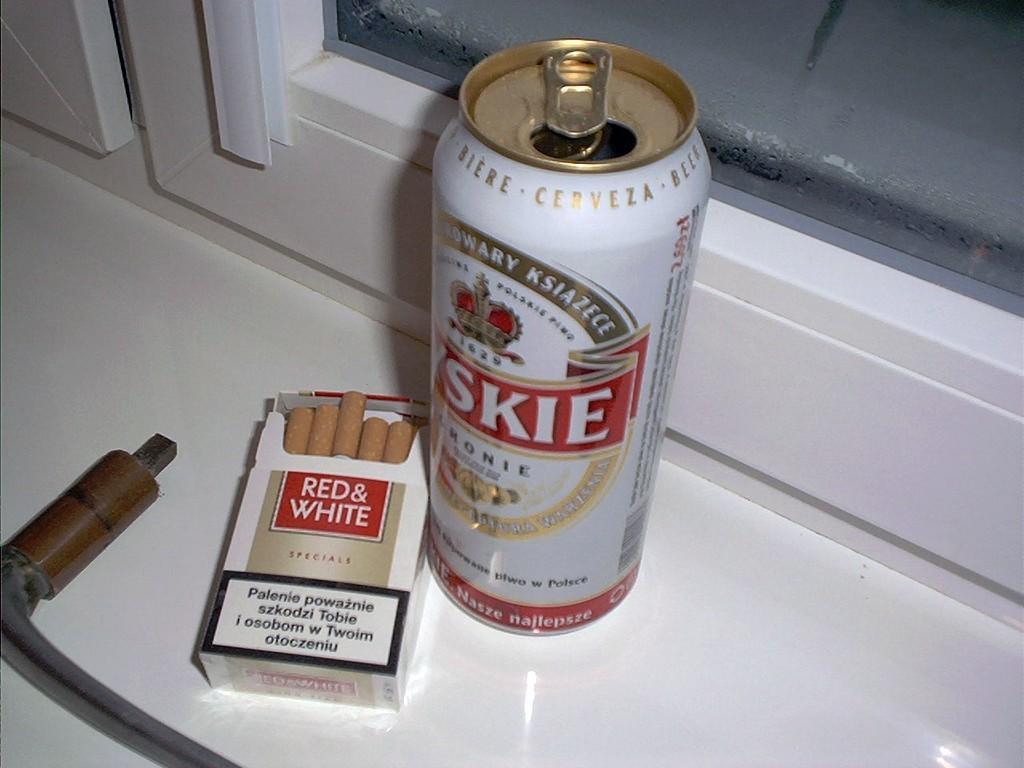Can you describe this image briefly? In the picture there is a cigarette pack with cigars in it, beside there is a tin, on the tin there is some text present and there is a metal object present, inside the tin there is a glass window present. 